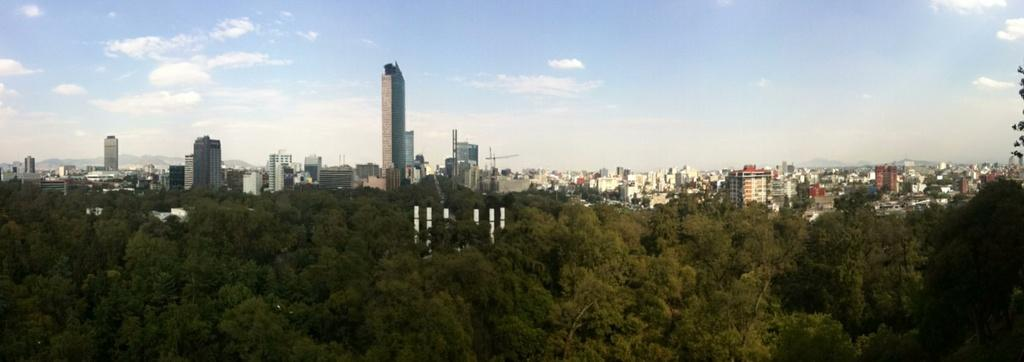What type of structures can be seen in the image? There are many buildings in the image. What other natural elements are present in the image? There are trees in the image. What can be seen in the background of the image? The sky is visible in the background of the image. What is the title of the book that the servant is reading in the image? There is no book or servant present in the image; it features many buildings and trees. 